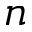<formula> <loc_0><loc_0><loc_500><loc_500>n</formula> 